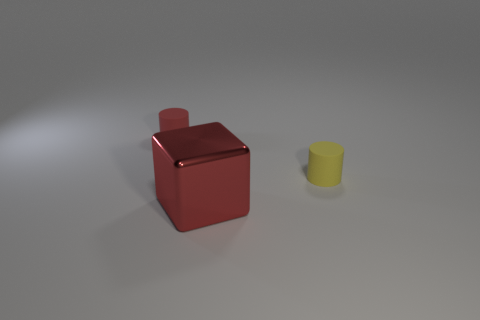Add 2 big red metallic things. How many objects exist? 5 Subtract all yellow cylinders. How many cylinders are left? 1 Subtract 0 yellow spheres. How many objects are left? 3 Subtract all cylinders. How many objects are left? 1 Subtract all cyan cylinders. Subtract all green balls. How many cylinders are left? 2 Subtract all matte objects. Subtract all big red cubes. How many objects are left? 0 Add 3 small red cylinders. How many small red cylinders are left? 4 Add 1 red shiny objects. How many red shiny objects exist? 2 